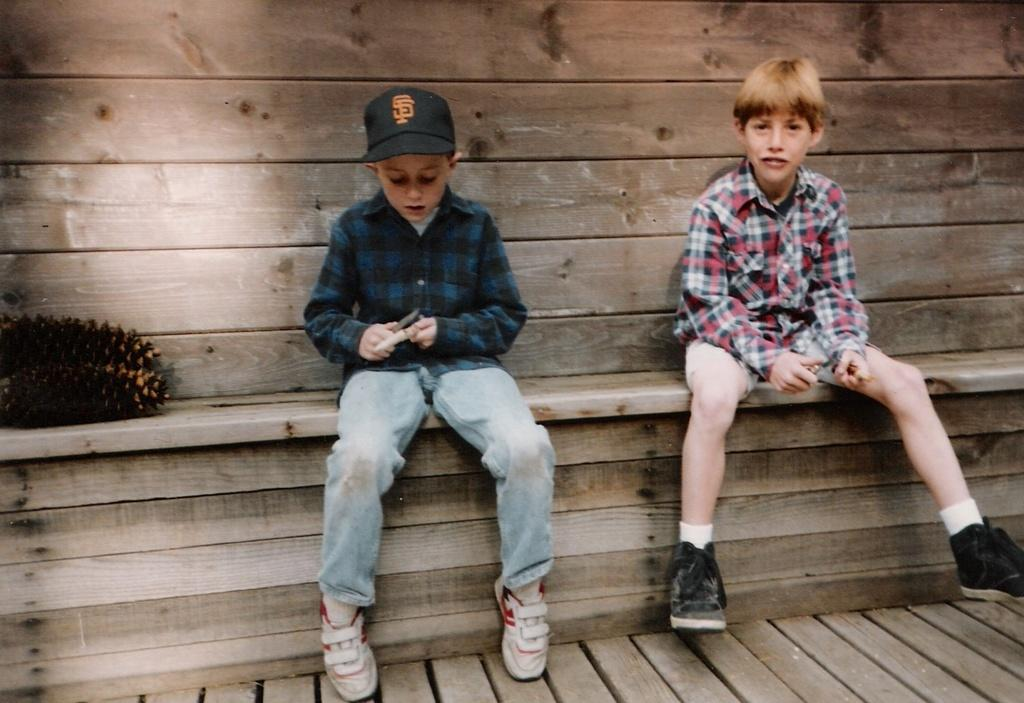How many boys are in the image? There are two boys in the image. What are the boys doing in the image? The boys are sitting on a wooden plank. Can you describe the clothing of one of the boys? One of the boys is wearing a cap. What type of material is visible in the background of the image? There is a wooden wall visible in the background of the image. What type of mint is growing near the wooden wall in the image? There is no mint visible in the image; only the wooden wall is present in the background. 